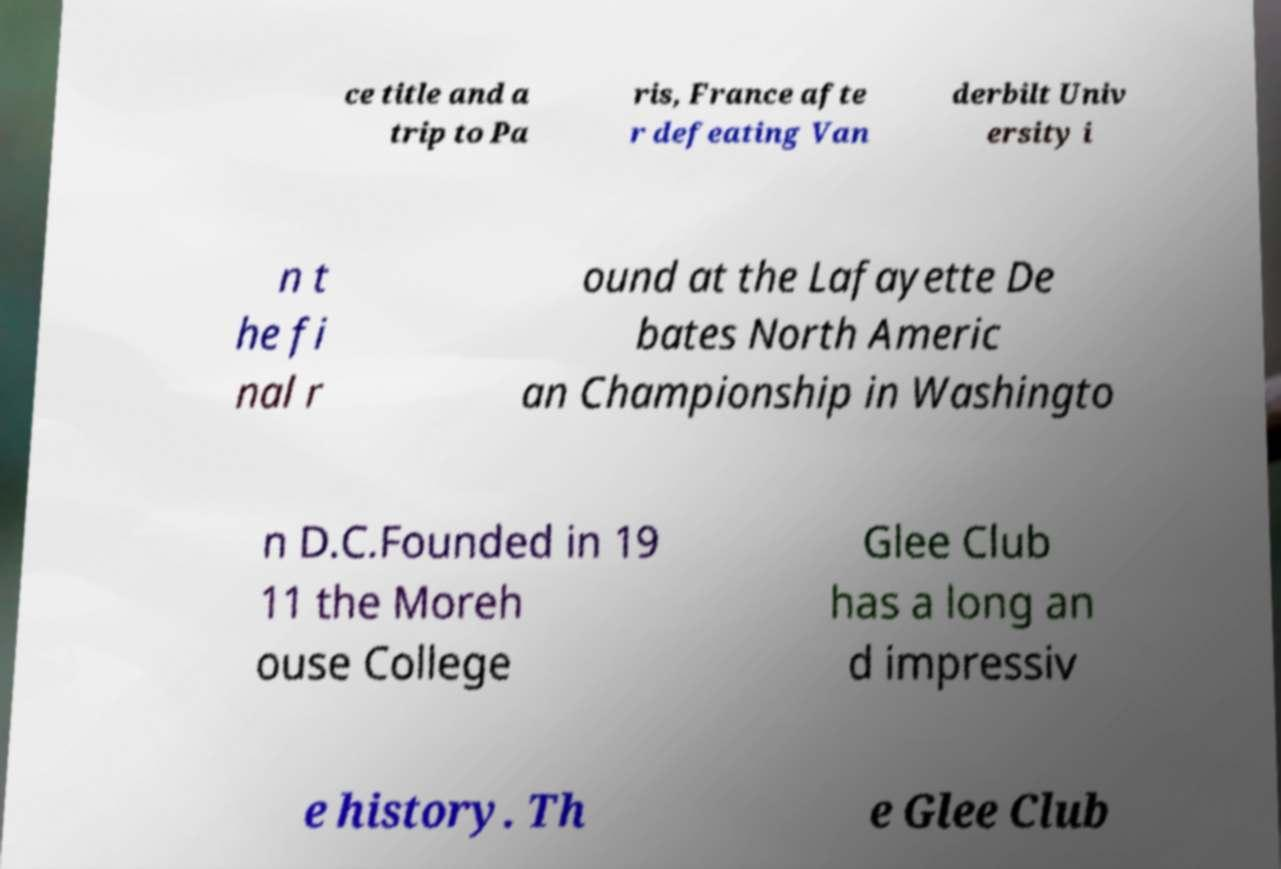There's text embedded in this image that I need extracted. Can you transcribe it verbatim? ce title and a trip to Pa ris, France afte r defeating Van derbilt Univ ersity i n t he fi nal r ound at the Lafayette De bates North Americ an Championship in Washingto n D.C.Founded in 19 11 the Moreh ouse College Glee Club has a long an d impressiv e history. Th e Glee Club 